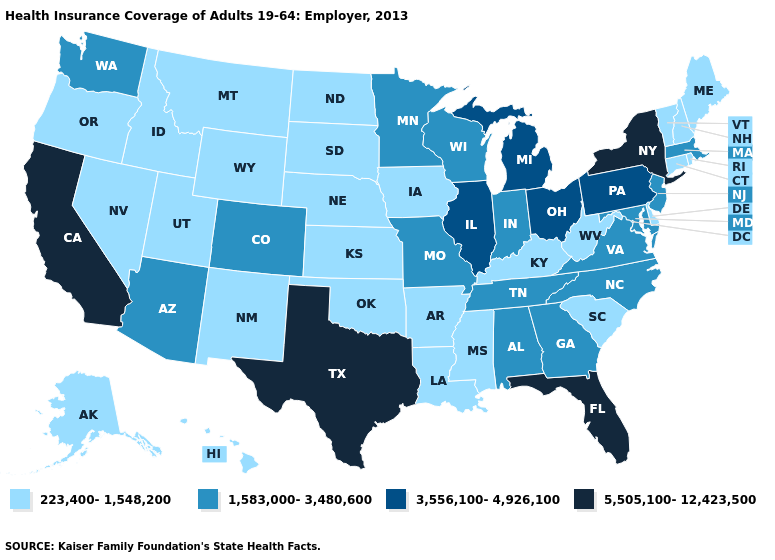Which states have the lowest value in the USA?
Give a very brief answer. Alaska, Arkansas, Connecticut, Delaware, Hawaii, Idaho, Iowa, Kansas, Kentucky, Louisiana, Maine, Mississippi, Montana, Nebraska, Nevada, New Hampshire, New Mexico, North Dakota, Oklahoma, Oregon, Rhode Island, South Carolina, South Dakota, Utah, Vermont, West Virginia, Wyoming. Does Ohio have the highest value in the MidWest?
Answer briefly. Yes. What is the value of Florida?
Be succinct. 5,505,100-12,423,500. What is the lowest value in states that border Louisiana?
Short answer required. 223,400-1,548,200. Name the states that have a value in the range 1,583,000-3,480,600?
Short answer required. Alabama, Arizona, Colorado, Georgia, Indiana, Maryland, Massachusetts, Minnesota, Missouri, New Jersey, North Carolina, Tennessee, Virginia, Washington, Wisconsin. Does West Virginia have the highest value in the USA?
Concise answer only. No. What is the lowest value in the USA?
Be succinct. 223,400-1,548,200. Name the states that have a value in the range 5,505,100-12,423,500?
Be succinct. California, Florida, New York, Texas. Does Delaware have the lowest value in the South?
Short answer required. Yes. What is the value of New Hampshire?
Be succinct. 223,400-1,548,200. Does Hawaii have the highest value in the USA?
Quick response, please. No. What is the highest value in states that border Oklahoma?
Short answer required. 5,505,100-12,423,500. Among the states that border Delaware , which have the highest value?
Answer briefly. Pennsylvania. Does the first symbol in the legend represent the smallest category?
Answer briefly. Yes. What is the value of Oklahoma?
Keep it brief. 223,400-1,548,200. 